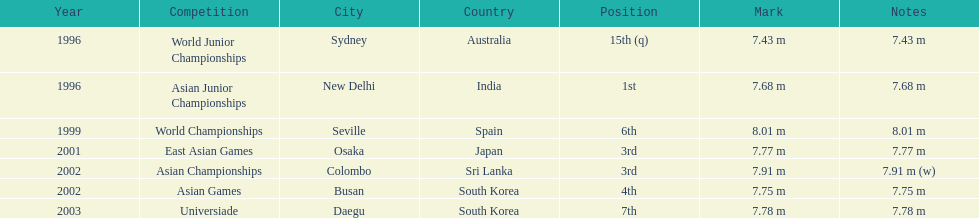Tell me the only venue in spain. Seville, Spain. 